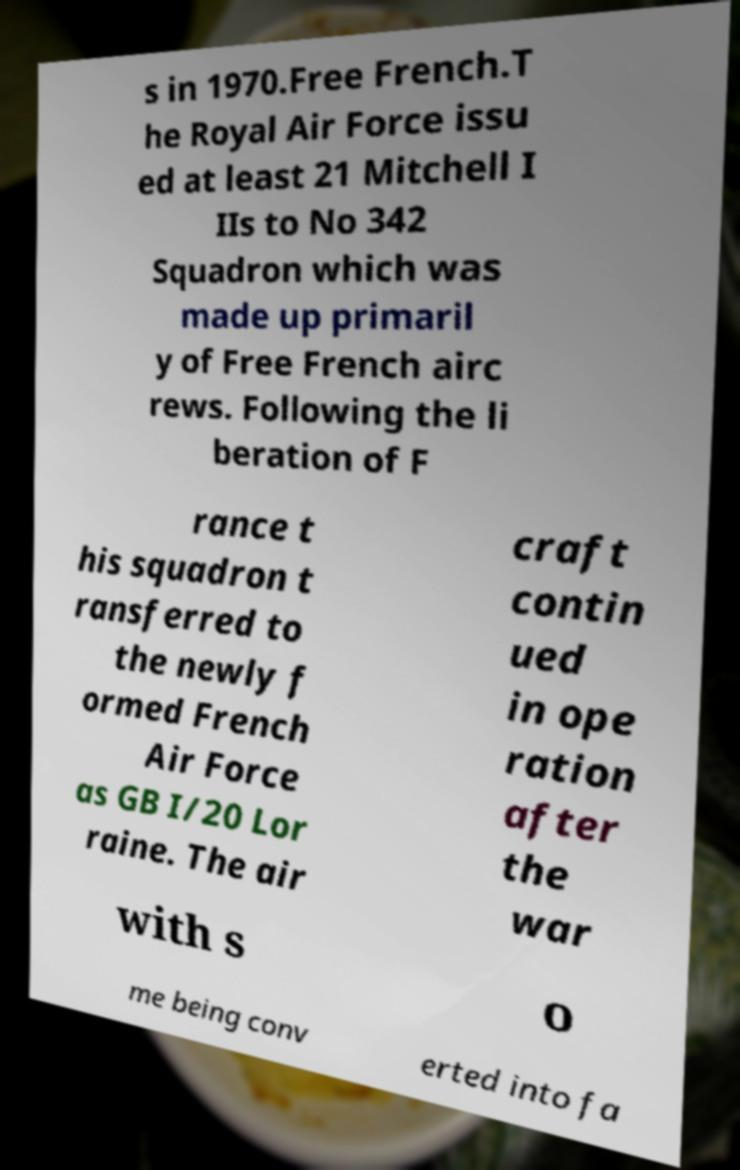I need the written content from this picture converted into text. Can you do that? s in 1970.Free French.T he Royal Air Force issu ed at least 21 Mitchell I IIs to No 342 Squadron which was made up primaril y of Free French airc rews. Following the li beration of F rance t his squadron t ransferred to the newly f ormed French Air Force as GB I/20 Lor raine. The air craft contin ued in ope ration after the war with s o me being conv erted into fa 